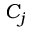<formula> <loc_0><loc_0><loc_500><loc_500>C _ { j }</formula> 